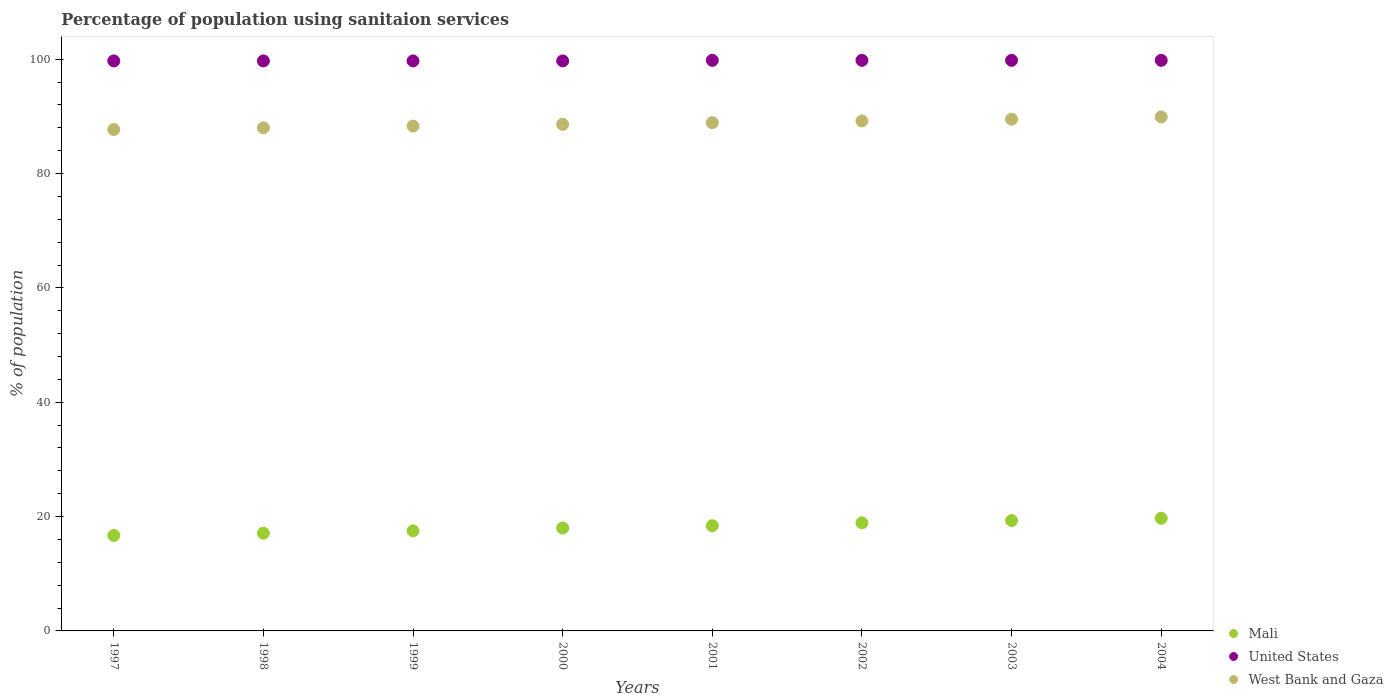Is the number of dotlines equal to the number of legend labels?
Give a very brief answer. Yes. What is the percentage of population using sanitaion services in United States in 1998?
Provide a short and direct response. 99.7. Across all years, what is the maximum percentage of population using sanitaion services in West Bank and Gaza?
Your response must be concise. 89.9. Across all years, what is the minimum percentage of population using sanitaion services in United States?
Offer a very short reply. 99.7. What is the total percentage of population using sanitaion services in United States in the graph?
Offer a very short reply. 798. What is the difference between the percentage of population using sanitaion services in United States in 2001 and that in 2002?
Make the answer very short. 0. What is the difference between the percentage of population using sanitaion services in United States in 1997 and the percentage of population using sanitaion services in West Bank and Gaza in 2001?
Make the answer very short. 10.8. What is the average percentage of population using sanitaion services in West Bank and Gaza per year?
Your response must be concise. 88.76. In the year 2004, what is the difference between the percentage of population using sanitaion services in United States and percentage of population using sanitaion services in Mali?
Ensure brevity in your answer.  80.1. In how many years, is the percentage of population using sanitaion services in West Bank and Gaza greater than 28 %?
Your answer should be compact. 8. What is the ratio of the percentage of population using sanitaion services in Mali in 1997 to that in 2001?
Offer a terse response. 0.91. What is the difference between the highest and the second highest percentage of population using sanitaion services in Mali?
Your answer should be compact. 0.4. What is the difference between the highest and the lowest percentage of population using sanitaion services in West Bank and Gaza?
Offer a terse response. 2.2. Is the sum of the percentage of population using sanitaion services in West Bank and Gaza in 1997 and 2000 greater than the maximum percentage of population using sanitaion services in United States across all years?
Your answer should be compact. Yes. Does the percentage of population using sanitaion services in Mali monotonically increase over the years?
Make the answer very short. Yes. Is the percentage of population using sanitaion services in West Bank and Gaza strictly less than the percentage of population using sanitaion services in Mali over the years?
Offer a terse response. No. Where does the legend appear in the graph?
Keep it short and to the point. Bottom right. How many legend labels are there?
Make the answer very short. 3. What is the title of the graph?
Offer a terse response. Percentage of population using sanitaion services. Does "OECD members" appear as one of the legend labels in the graph?
Give a very brief answer. No. What is the label or title of the Y-axis?
Make the answer very short. % of population. What is the % of population of Mali in 1997?
Make the answer very short. 16.7. What is the % of population in United States in 1997?
Your answer should be compact. 99.7. What is the % of population of West Bank and Gaza in 1997?
Your response must be concise. 87.7. What is the % of population of Mali in 1998?
Offer a terse response. 17.1. What is the % of population in United States in 1998?
Provide a short and direct response. 99.7. What is the % of population of United States in 1999?
Your answer should be very brief. 99.7. What is the % of population in West Bank and Gaza in 1999?
Your answer should be compact. 88.3. What is the % of population of United States in 2000?
Offer a very short reply. 99.7. What is the % of population of West Bank and Gaza in 2000?
Make the answer very short. 88.6. What is the % of population in Mali in 2001?
Provide a short and direct response. 18.4. What is the % of population in United States in 2001?
Make the answer very short. 99.8. What is the % of population of West Bank and Gaza in 2001?
Make the answer very short. 88.9. What is the % of population of Mali in 2002?
Your answer should be very brief. 18.9. What is the % of population of United States in 2002?
Ensure brevity in your answer.  99.8. What is the % of population of West Bank and Gaza in 2002?
Your response must be concise. 89.2. What is the % of population of Mali in 2003?
Keep it short and to the point. 19.3. What is the % of population of United States in 2003?
Make the answer very short. 99.8. What is the % of population of West Bank and Gaza in 2003?
Your response must be concise. 89.5. What is the % of population in Mali in 2004?
Provide a succinct answer. 19.7. What is the % of population in United States in 2004?
Your response must be concise. 99.8. What is the % of population of West Bank and Gaza in 2004?
Ensure brevity in your answer.  89.9. Across all years, what is the maximum % of population in United States?
Keep it short and to the point. 99.8. Across all years, what is the maximum % of population in West Bank and Gaza?
Give a very brief answer. 89.9. Across all years, what is the minimum % of population in Mali?
Your response must be concise. 16.7. Across all years, what is the minimum % of population in United States?
Keep it short and to the point. 99.7. Across all years, what is the minimum % of population of West Bank and Gaza?
Make the answer very short. 87.7. What is the total % of population of Mali in the graph?
Your response must be concise. 145.6. What is the total % of population in United States in the graph?
Your response must be concise. 798. What is the total % of population in West Bank and Gaza in the graph?
Provide a succinct answer. 710.1. What is the difference between the % of population in Mali in 1997 and that in 1998?
Provide a succinct answer. -0.4. What is the difference between the % of population in West Bank and Gaza in 1997 and that in 1998?
Offer a very short reply. -0.3. What is the difference between the % of population in Mali in 1997 and that in 1999?
Make the answer very short. -0.8. What is the difference between the % of population of United States in 1997 and that in 1999?
Give a very brief answer. 0. What is the difference between the % of population of West Bank and Gaza in 1997 and that in 1999?
Provide a short and direct response. -0.6. What is the difference between the % of population of United States in 1997 and that in 2000?
Offer a very short reply. 0. What is the difference between the % of population in West Bank and Gaza in 1997 and that in 2000?
Give a very brief answer. -0.9. What is the difference between the % of population of United States in 1997 and that in 2001?
Ensure brevity in your answer.  -0.1. What is the difference between the % of population of West Bank and Gaza in 1997 and that in 2001?
Provide a short and direct response. -1.2. What is the difference between the % of population in United States in 1997 and that in 2002?
Provide a short and direct response. -0.1. What is the difference between the % of population in West Bank and Gaza in 1997 and that in 2002?
Your answer should be compact. -1.5. What is the difference between the % of population in United States in 1997 and that in 2003?
Ensure brevity in your answer.  -0.1. What is the difference between the % of population of West Bank and Gaza in 1997 and that in 2004?
Offer a terse response. -2.2. What is the difference between the % of population in Mali in 1998 and that in 1999?
Make the answer very short. -0.4. What is the difference between the % of population in United States in 1998 and that in 1999?
Provide a short and direct response. 0. What is the difference between the % of population of Mali in 1998 and that in 2000?
Give a very brief answer. -0.9. What is the difference between the % of population of United States in 1998 and that in 2000?
Your answer should be very brief. 0. What is the difference between the % of population of West Bank and Gaza in 1998 and that in 2002?
Offer a very short reply. -1.2. What is the difference between the % of population of Mali in 1998 and that in 2003?
Your response must be concise. -2.2. What is the difference between the % of population of United States in 1998 and that in 2004?
Provide a succinct answer. -0.1. What is the difference between the % of population of West Bank and Gaza in 1998 and that in 2004?
Make the answer very short. -1.9. What is the difference between the % of population in Mali in 1999 and that in 2000?
Give a very brief answer. -0.5. What is the difference between the % of population of United States in 1999 and that in 2000?
Make the answer very short. 0. What is the difference between the % of population of West Bank and Gaza in 1999 and that in 2000?
Give a very brief answer. -0.3. What is the difference between the % of population of United States in 1999 and that in 2001?
Your answer should be very brief. -0.1. What is the difference between the % of population in Mali in 1999 and that in 2002?
Offer a very short reply. -1.4. What is the difference between the % of population of United States in 1999 and that in 2002?
Make the answer very short. -0.1. What is the difference between the % of population of West Bank and Gaza in 1999 and that in 2002?
Keep it short and to the point. -0.9. What is the difference between the % of population in Mali in 1999 and that in 2003?
Offer a very short reply. -1.8. What is the difference between the % of population of United States in 1999 and that in 2003?
Ensure brevity in your answer.  -0.1. What is the difference between the % of population in Mali in 1999 and that in 2004?
Your response must be concise. -2.2. What is the difference between the % of population in United States in 1999 and that in 2004?
Provide a succinct answer. -0.1. What is the difference between the % of population of United States in 2000 and that in 2001?
Your answer should be compact. -0.1. What is the difference between the % of population of Mali in 2000 and that in 2002?
Give a very brief answer. -0.9. What is the difference between the % of population in United States in 2000 and that in 2002?
Ensure brevity in your answer.  -0.1. What is the difference between the % of population of Mali in 2000 and that in 2003?
Keep it short and to the point. -1.3. What is the difference between the % of population of United States in 2000 and that in 2003?
Keep it short and to the point. -0.1. What is the difference between the % of population of West Bank and Gaza in 2000 and that in 2003?
Your answer should be compact. -0.9. What is the difference between the % of population in Mali in 2000 and that in 2004?
Provide a succinct answer. -1.7. What is the difference between the % of population in West Bank and Gaza in 2000 and that in 2004?
Offer a terse response. -1.3. What is the difference between the % of population of Mali in 2001 and that in 2002?
Your response must be concise. -0.5. What is the difference between the % of population of West Bank and Gaza in 2001 and that in 2002?
Your answer should be compact. -0.3. What is the difference between the % of population of Mali in 2001 and that in 2003?
Offer a terse response. -0.9. What is the difference between the % of population of United States in 2001 and that in 2003?
Keep it short and to the point. 0. What is the difference between the % of population in West Bank and Gaza in 2001 and that in 2003?
Provide a succinct answer. -0.6. What is the difference between the % of population in United States in 2001 and that in 2004?
Make the answer very short. 0. What is the difference between the % of population in West Bank and Gaza in 2001 and that in 2004?
Offer a very short reply. -1. What is the difference between the % of population in Mali in 2002 and that in 2003?
Your answer should be very brief. -0.4. What is the difference between the % of population of West Bank and Gaza in 2002 and that in 2003?
Make the answer very short. -0.3. What is the difference between the % of population in Mali in 2002 and that in 2004?
Ensure brevity in your answer.  -0.8. What is the difference between the % of population in Mali in 1997 and the % of population in United States in 1998?
Make the answer very short. -83. What is the difference between the % of population in Mali in 1997 and the % of population in West Bank and Gaza in 1998?
Ensure brevity in your answer.  -71.3. What is the difference between the % of population in United States in 1997 and the % of population in West Bank and Gaza in 1998?
Give a very brief answer. 11.7. What is the difference between the % of population of Mali in 1997 and the % of population of United States in 1999?
Make the answer very short. -83. What is the difference between the % of population of Mali in 1997 and the % of population of West Bank and Gaza in 1999?
Offer a terse response. -71.6. What is the difference between the % of population of United States in 1997 and the % of population of West Bank and Gaza in 1999?
Your answer should be compact. 11.4. What is the difference between the % of population in Mali in 1997 and the % of population in United States in 2000?
Offer a very short reply. -83. What is the difference between the % of population of Mali in 1997 and the % of population of West Bank and Gaza in 2000?
Your response must be concise. -71.9. What is the difference between the % of population in United States in 1997 and the % of population in West Bank and Gaza in 2000?
Your response must be concise. 11.1. What is the difference between the % of population of Mali in 1997 and the % of population of United States in 2001?
Your answer should be very brief. -83.1. What is the difference between the % of population of Mali in 1997 and the % of population of West Bank and Gaza in 2001?
Keep it short and to the point. -72.2. What is the difference between the % of population in Mali in 1997 and the % of population in United States in 2002?
Keep it short and to the point. -83.1. What is the difference between the % of population of Mali in 1997 and the % of population of West Bank and Gaza in 2002?
Offer a terse response. -72.5. What is the difference between the % of population of United States in 1997 and the % of population of West Bank and Gaza in 2002?
Your answer should be very brief. 10.5. What is the difference between the % of population of Mali in 1997 and the % of population of United States in 2003?
Offer a very short reply. -83.1. What is the difference between the % of population in Mali in 1997 and the % of population in West Bank and Gaza in 2003?
Provide a short and direct response. -72.8. What is the difference between the % of population of Mali in 1997 and the % of population of United States in 2004?
Give a very brief answer. -83.1. What is the difference between the % of population of Mali in 1997 and the % of population of West Bank and Gaza in 2004?
Offer a terse response. -73.2. What is the difference between the % of population of United States in 1997 and the % of population of West Bank and Gaza in 2004?
Provide a succinct answer. 9.8. What is the difference between the % of population in Mali in 1998 and the % of population in United States in 1999?
Offer a very short reply. -82.6. What is the difference between the % of population of Mali in 1998 and the % of population of West Bank and Gaza in 1999?
Keep it short and to the point. -71.2. What is the difference between the % of population in Mali in 1998 and the % of population in United States in 2000?
Offer a terse response. -82.6. What is the difference between the % of population of Mali in 1998 and the % of population of West Bank and Gaza in 2000?
Ensure brevity in your answer.  -71.5. What is the difference between the % of population in Mali in 1998 and the % of population in United States in 2001?
Offer a very short reply. -82.7. What is the difference between the % of population in Mali in 1998 and the % of population in West Bank and Gaza in 2001?
Keep it short and to the point. -71.8. What is the difference between the % of population of United States in 1998 and the % of population of West Bank and Gaza in 2001?
Your answer should be very brief. 10.8. What is the difference between the % of population in Mali in 1998 and the % of population in United States in 2002?
Provide a succinct answer. -82.7. What is the difference between the % of population in Mali in 1998 and the % of population in West Bank and Gaza in 2002?
Offer a terse response. -72.1. What is the difference between the % of population of Mali in 1998 and the % of population of United States in 2003?
Keep it short and to the point. -82.7. What is the difference between the % of population of Mali in 1998 and the % of population of West Bank and Gaza in 2003?
Offer a terse response. -72.4. What is the difference between the % of population of Mali in 1998 and the % of population of United States in 2004?
Your response must be concise. -82.7. What is the difference between the % of population in Mali in 1998 and the % of population in West Bank and Gaza in 2004?
Ensure brevity in your answer.  -72.8. What is the difference between the % of population in Mali in 1999 and the % of population in United States in 2000?
Keep it short and to the point. -82.2. What is the difference between the % of population of Mali in 1999 and the % of population of West Bank and Gaza in 2000?
Keep it short and to the point. -71.1. What is the difference between the % of population of United States in 1999 and the % of population of West Bank and Gaza in 2000?
Offer a very short reply. 11.1. What is the difference between the % of population in Mali in 1999 and the % of population in United States in 2001?
Your answer should be very brief. -82.3. What is the difference between the % of population of Mali in 1999 and the % of population of West Bank and Gaza in 2001?
Provide a succinct answer. -71.4. What is the difference between the % of population of Mali in 1999 and the % of population of United States in 2002?
Offer a terse response. -82.3. What is the difference between the % of population of Mali in 1999 and the % of population of West Bank and Gaza in 2002?
Ensure brevity in your answer.  -71.7. What is the difference between the % of population in Mali in 1999 and the % of population in United States in 2003?
Ensure brevity in your answer.  -82.3. What is the difference between the % of population in Mali in 1999 and the % of population in West Bank and Gaza in 2003?
Ensure brevity in your answer.  -72. What is the difference between the % of population of Mali in 1999 and the % of population of United States in 2004?
Your response must be concise. -82.3. What is the difference between the % of population of Mali in 1999 and the % of population of West Bank and Gaza in 2004?
Offer a very short reply. -72.4. What is the difference between the % of population of Mali in 2000 and the % of population of United States in 2001?
Ensure brevity in your answer.  -81.8. What is the difference between the % of population in Mali in 2000 and the % of population in West Bank and Gaza in 2001?
Provide a short and direct response. -70.9. What is the difference between the % of population of Mali in 2000 and the % of population of United States in 2002?
Make the answer very short. -81.8. What is the difference between the % of population in Mali in 2000 and the % of population in West Bank and Gaza in 2002?
Make the answer very short. -71.2. What is the difference between the % of population of Mali in 2000 and the % of population of United States in 2003?
Your answer should be very brief. -81.8. What is the difference between the % of population in Mali in 2000 and the % of population in West Bank and Gaza in 2003?
Give a very brief answer. -71.5. What is the difference between the % of population in United States in 2000 and the % of population in West Bank and Gaza in 2003?
Ensure brevity in your answer.  10.2. What is the difference between the % of population of Mali in 2000 and the % of population of United States in 2004?
Provide a succinct answer. -81.8. What is the difference between the % of population of Mali in 2000 and the % of population of West Bank and Gaza in 2004?
Provide a succinct answer. -71.9. What is the difference between the % of population of United States in 2000 and the % of population of West Bank and Gaza in 2004?
Offer a very short reply. 9.8. What is the difference between the % of population of Mali in 2001 and the % of population of United States in 2002?
Your answer should be very brief. -81.4. What is the difference between the % of population in Mali in 2001 and the % of population in West Bank and Gaza in 2002?
Give a very brief answer. -70.8. What is the difference between the % of population of Mali in 2001 and the % of population of United States in 2003?
Provide a succinct answer. -81.4. What is the difference between the % of population in Mali in 2001 and the % of population in West Bank and Gaza in 2003?
Your answer should be very brief. -71.1. What is the difference between the % of population of United States in 2001 and the % of population of West Bank and Gaza in 2003?
Your answer should be compact. 10.3. What is the difference between the % of population in Mali in 2001 and the % of population in United States in 2004?
Give a very brief answer. -81.4. What is the difference between the % of population of Mali in 2001 and the % of population of West Bank and Gaza in 2004?
Your answer should be very brief. -71.5. What is the difference between the % of population of United States in 2001 and the % of population of West Bank and Gaza in 2004?
Provide a short and direct response. 9.9. What is the difference between the % of population of Mali in 2002 and the % of population of United States in 2003?
Make the answer very short. -80.9. What is the difference between the % of population of Mali in 2002 and the % of population of West Bank and Gaza in 2003?
Keep it short and to the point. -70.6. What is the difference between the % of population of Mali in 2002 and the % of population of United States in 2004?
Provide a succinct answer. -80.9. What is the difference between the % of population in Mali in 2002 and the % of population in West Bank and Gaza in 2004?
Offer a terse response. -71. What is the difference between the % of population in United States in 2002 and the % of population in West Bank and Gaza in 2004?
Offer a very short reply. 9.9. What is the difference between the % of population in Mali in 2003 and the % of population in United States in 2004?
Ensure brevity in your answer.  -80.5. What is the difference between the % of population of Mali in 2003 and the % of population of West Bank and Gaza in 2004?
Provide a short and direct response. -70.6. What is the difference between the % of population of United States in 2003 and the % of population of West Bank and Gaza in 2004?
Your answer should be very brief. 9.9. What is the average % of population in Mali per year?
Your answer should be compact. 18.2. What is the average % of population in United States per year?
Your answer should be very brief. 99.75. What is the average % of population in West Bank and Gaza per year?
Offer a terse response. 88.76. In the year 1997, what is the difference between the % of population in Mali and % of population in United States?
Your answer should be compact. -83. In the year 1997, what is the difference between the % of population in Mali and % of population in West Bank and Gaza?
Your answer should be very brief. -71. In the year 1998, what is the difference between the % of population in Mali and % of population in United States?
Your answer should be compact. -82.6. In the year 1998, what is the difference between the % of population in Mali and % of population in West Bank and Gaza?
Keep it short and to the point. -70.9. In the year 1998, what is the difference between the % of population of United States and % of population of West Bank and Gaza?
Ensure brevity in your answer.  11.7. In the year 1999, what is the difference between the % of population of Mali and % of population of United States?
Give a very brief answer. -82.2. In the year 1999, what is the difference between the % of population of Mali and % of population of West Bank and Gaza?
Keep it short and to the point. -70.8. In the year 1999, what is the difference between the % of population of United States and % of population of West Bank and Gaza?
Give a very brief answer. 11.4. In the year 2000, what is the difference between the % of population of Mali and % of population of United States?
Offer a terse response. -81.7. In the year 2000, what is the difference between the % of population in Mali and % of population in West Bank and Gaza?
Provide a short and direct response. -70.6. In the year 2000, what is the difference between the % of population of United States and % of population of West Bank and Gaza?
Keep it short and to the point. 11.1. In the year 2001, what is the difference between the % of population of Mali and % of population of United States?
Your response must be concise. -81.4. In the year 2001, what is the difference between the % of population of Mali and % of population of West Bank and Gaza?
Your response must be concise. -70.5. In the year 2002, what is the difference between the % of population of Mali and % of population of United States?
Ensure brevity in your answer.  -80.9. In the year 2002, what is the difference between the % of population in Mali and % of population in West Bank and Gaza?
Provide a succinct answer. -70.3. In the year 2002, what is the difference between the % of population of United States and % of population of West Bank and Gaza?
Your answer should be compact. 10.6. In the year 2003, what is the difference between the % of population of Mali and % of population of United States?
Provide a short and direct response. -80.5. In the year 2003, what is the difference between the % of population in Mali and % of population in West Bank and Gaza?
Provide a succinct answer. -70.2. In the year 2004, what is the difference between the % of population of Mali and % of population of United States?
Ensure brevity in your answer.  -80.1. In the year 2004, what is the difference between the % of population of Mali and % of population of West Bank and Gaza?
Offer a terse response. -70.2. In the year 2004, what is the difference between the % of population of United States and % of population of West Bank and Gaza?
Provide a short and direct response. 9.9. What is the ratio of the % of population in Mali in 1997 to that in 1998?
Offer a very short reply. 0.98. What is the ratio of the % of population in West Bank and Gaza in 1997 to that in 1998?
Ensure brevity in your answer.  1. What is the ratio of the % of population in Mali in 1997 to that in 1999?
Ensure brevity in your answer.  0.95. What is the ratio of the % of population of United States in 1997 to that in 1999?
Offer a terse response. 1. What is the ratio of the % of population in West Bank and Gaza in 1997 to that in 1999?
Your response must be concise. 0.99. What is the ratio of the % of population of Mali in 1997 to that in 2000?
Your answer should be very brief. 0.93. What is the ratio of the % of population of United States in 1997 to that in 2000?
Your answer should be compact. 1. What is the ratio of the % of population of West Bank and Gaza in 1997 to that in 2000?
Provide a short and direct response. 0.99. What is the ratio of the % of population in Mali in 1997 to that in 2001?
Provide a succinct answer. 0.91. What is the ratio of the % of population of West Bank and Gaza in 1997 to that in 2001?
Your response must be concise. 0.99. What is the ratio of the % of population in Mali in 1997 to that in 2002?
Ensure brevity in your answer.  0.88. What is the ratio of the % of population in West Bank and Gaza in 1997 to that in 2002?
Your answer should be compact. 0.98. What is the ratio of the % of population of Mali in 1997 to that in 2003?
Offer a terse response. 0.87. What is the ratio of the % of population of West Bank and Gaza in 1997 to that in 2003?
Ensure brevity in your answer.  0.98. What is the ratio of the % of population in Mali in 1997 to that in 2004?
Make the answer very short. 0.85. What is the ratio of the % of population of West Bank and Gaza in 1997 to that in 2004?
Your response must be concise. 0.98. What is the ratio of the % of population of Mali in 1998 to that in 1999?
Make the answer very short. 0.98. What is the ratio of the % of population of West Bank and Gaza in 1998 to that in 1999?
Keep it short and to the point. 1. What is the ratio of the % of population in Mali in 1998 to that in 2000?
Provide a short and direct response. 0.95. What is the ratio of the % of population of United States in 1998 to that in 2000?
Provide a short and direct response. 1. What is the ratio of the % of population in West Bank and Gaza in 1998 to that in 2000?
Your answer should be very brief. 0.99. What is the ratio of the % of population in Mali in 1998 to that in 2001?
Offer a terse response. 0.93. What is the ratio of the % of population in United States in 1998 to that in 2001?
Keep it short and to the point. 1. What is the ratio of the % of population in Mali in 1998 to that in 2002?
Your answer should be compact. 0.9. What is the ratio of the % of population in West Bank and Gaza in 1998 to that in 2002?
Make the answer very short. 0.99. What is the ratio of the % of population in Mali in 1998 to that in 2003?
Offer a very short reply. 0.89. What is the ratio of the % of population of West Bank and Gaza in 1998 to that in 2003?
Give a very brief answer. 0.98. What is the ratio of the % of population in Mali in 1998 to that in 2004?
Provide a short and direct response. 0.87. What is the ratio of the % of population of West Bank and Gaza in 1998 to that in 2004?
Provide a short and direct response. 0.98. What is the ratio of the % of population of Mali in 1999 to that in 2000?
Provide a short and direct response. 0.97. What is the ratio of the % of population in United States in 1999 to that in 2000?
Keep it short and to the point. 1. What is the ratio of the % of population in Mali in 1999 to that in 2001?
Provide a short and direct response. 0.95. What is the ratio of the % of population of West Bank and Gaza in 1999 to that in 2001?
Make the answer very short. 0.99. What is the ratio of the % of population in Mali in 1999 to that in 2002?
Keep it short and to the point. 0.93. What is the ratio of the % of population in United States in 1999 to that in 2002?
Make the answer very short. 1. What is the ratio of the % of population of Mali in 1999 to that in 2003?
Provide a short and direct response. 0.91. What is the ratio of the % of population in United States in 1999 to that in 2003?
Provide a succinct answer. 1. What is the ratio of the % of population of West Bank and Gaza in 1999 to that in 2003?
Your answer should be very brief. 0.99. What is the ratio of the % of population of Mali in 1999 to that in 2004?
Keep it short and to the point. 0.89. What is the ratio of the % of population in West Bank and Gaza in 1999 to that in 2004?
Provide a succinct answer. 0.98. What is the ratio of the % of population in Mali in 2000 to that in 2001?
Ensure brevity in your answer.  0.98. What is the ratio of the % of population in United States in 2000 to that in 2001?
Offer a very short reply. 1. What is the ratio of the % of population of Mali in 2000 to that in 2002?
Offer a terse response. 0.95. What is the ratio of the % of population in United States in 2000 to that in 2002?
Offer a terse response. 1. What is the ratio of the % of population in Mali in 2000 to that in 2003?
Provide a short and direct response. 0.93. What is the ratio of the % of population in West Bank and Gaza in 2000 to that in 2003?
Make the answer very short. 0.99. What is the ratio of the % of population in Mali in 2000 to that in 2004?
Give a very brief answer. 0.91. What is the ratio of the % of population in United States in 2000 to that in 2004?
Provide a succinct answer. 1. What is the ratio of the % of population in West Bank and Gaza in 2000 to that in 2004?
Make the answer very short. 0.99. What is the ratio of the % of population in Mali in 2001 to that in 2002?
Provide a succinct answer. 0.97. What is the ratio of the % of population in United States in 2001 to that in 2002?
Ensure brevity in your answer.  1. What is the ratio of the % of population of Mali in 2001 to that in 2003?
Offer a very short reply. 0.95. What is the ratio of the % of population in United States in 2001 to that in 2003?
Offer a terse response. 1. What is the ratio of the % of population of West Bank and Gaza in 2001 to that in 2003?
Make the answer very short. 0.99. What is the ratio of the % of population in Mali in 2001 to that in 2004?
Provide a succinct answer. 0.93. What is the ratio of the % of population of United States in 2001 to that in 2004?
Offer a terse response. 1. What is the ratio of the % of population in West Bank and Gaza in 2001 to that in 2004?
Make the answer very short. 0.99. What is the ratio of the % of population of Mali in 2002 to that in 2003?
Make the answer very short. 0.98. What is the ratio of the % of population in United States in 2002 to that in 2003?
Provide a succinct answer. 1. What is the ratio of the % of population in West Bank and Gaza in 2002 to that in 2003?
Provide a succinct answer. 1. What is the ratio of the % of population in Mali in 2002 to that in 2004?
Give a very brief answer. 0.96. What is the ratio of the % of population of United States in 2002 to that in 2004?
Provide a short and direct response. 1. What is the ratio of the % of population in West Bank and Gaza in 2002 to that in 2004?
Your answer should be compact. 0.99. What is the ratio of the % of population of Mali in 2003 to that in 2004?
Ensure brevity in your answer.  0.98. What is the ratio of the % of population of United States in 2003 to that in 2004?
Offer a terse response. 1. What is the ratio of the % of population of West Bank and Gaza in 2003 to that in 2004?
Provide a succinct answer. 1. What is the difference between the highest and the second highest % of population in United States?
Keep it short and to the point. 0. What is the difference between the highest and the lowest % of population of United States?
Ensure brevity in your answer.  0.1. 